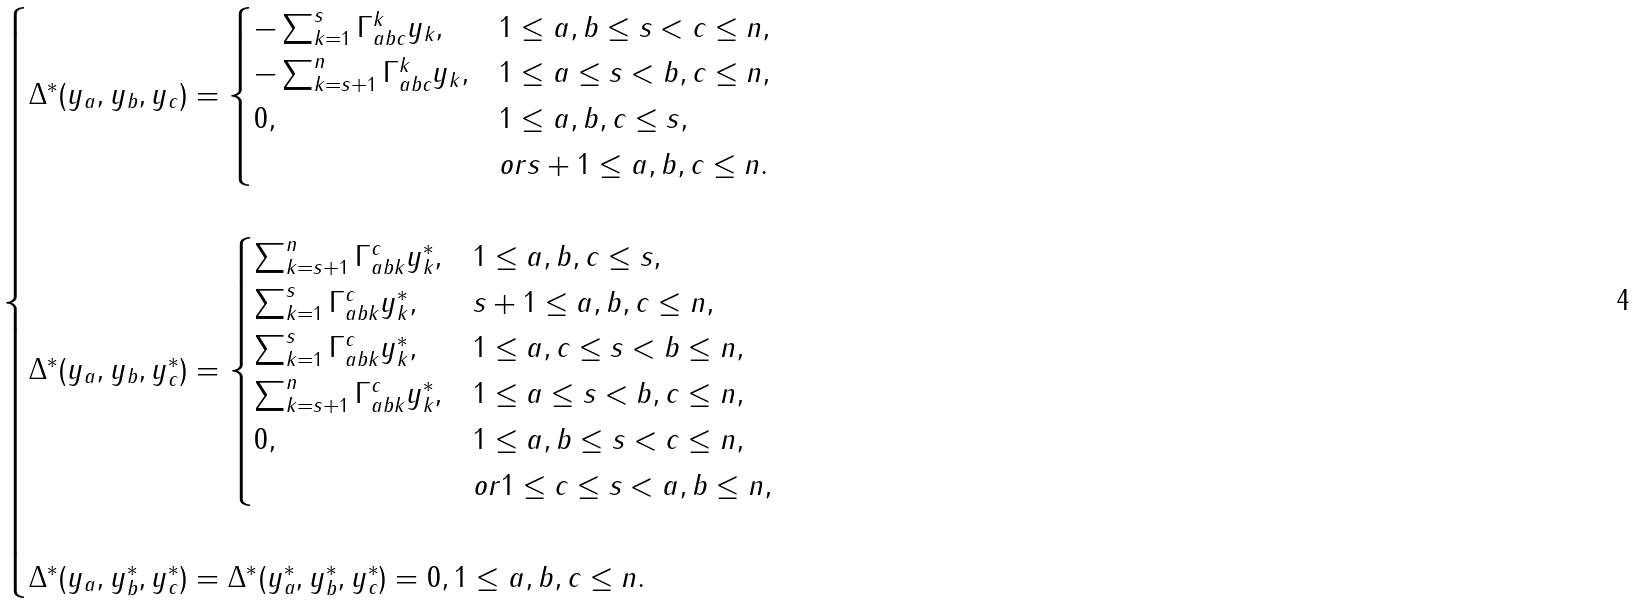Convert formula to latex. <formula><loc_0><loc_0><loc_500><loc_500>\begin{cases} \Delta ^ { * } ( y _ { a } , y _ { b } , y _ { c } ) = \begin{cases} - \sum _ { k = 1 } ^ { s } \Gamma ^ { k } _ { a b c } y _ { k } , & 1 \leq a , b \leq s < c \leq n , \\ - \sum _ { k = s + 1 } ^ { n } \Gamma ^ { k } _ { a b c } y _ { k } , & 1 \leq a \leq s < b , c \leq n , \\ 0 , & 1 \leq a , b , c \leq s , \\ & o r s + 1 \leq a , b , c \leq n . \\ \end{cases} \\ \\ \Delta ^ { * } ( y _ { a } , y _ { b } , y _ { c } ^ { * } ) = \begin{cases} \sum _ { k = s + 1 } ^ { n } \Gamma ^ { c } _ { a b k } y _ { k } ^ { * } , & 1 \leq a , b , c \leq s , \\ \sum _ { k = 1 } ^ { s } \Gamma ^ { c } _ { a b k } y _ { k } ^ { * } , & s + 1 \leq a , b , c \leq n , \\ \sum _ { k = 1 } ^ { s } \Gamma ^ { c } _ { a b k } y _ { k } ^ { * } , & 1 \leq a , c \leq s < b \leq n , \\ \sum _ { k = s + 1 } ^ { n } \Gamma ^ { c } _ { a b k } y _ { k } ^ { * } , & 1 \leq a \leq s < b , c \leq n , \\ 0 , & 1 \leq a , b \leq s < c \leq n , \\ & o r 1 \leq c \leq s < a , b \leq n , \\ \end{cases} \\ \\ \Delta ^ { * } ( y _ { a } , y _ { b } ^ { * } , y _ { c } ^ { * } ) = \Delta ^ { * } ( y _ { a } ^ { * } , y _ { b } ^ { * } , y _ { c } ^ { * } ) = 0 , 1 \leq a , b , c \leq n . \end{cases}</formula> 